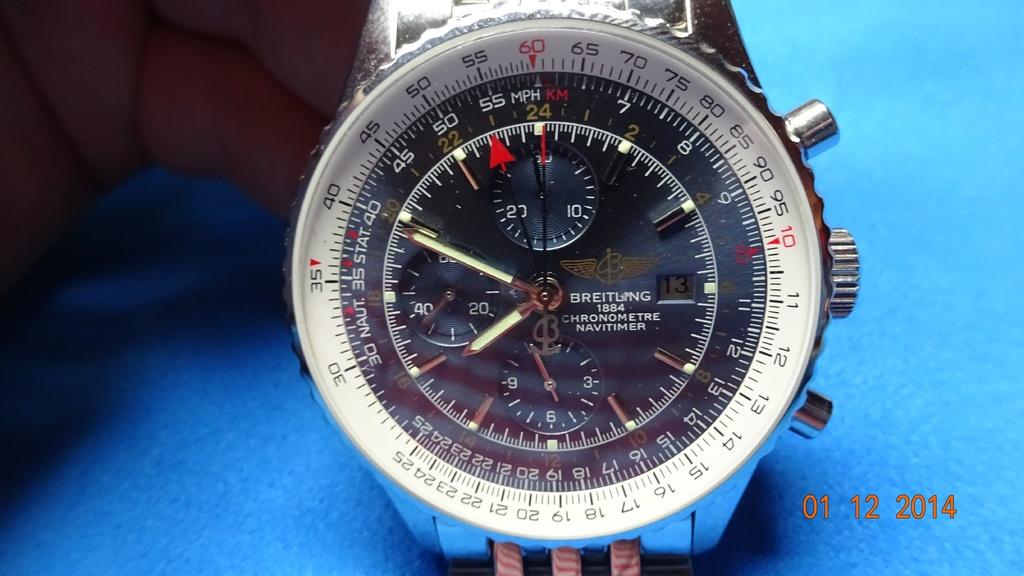What time is on the watch?
Ensure brevity in your answer.  7:49. What is the brand of the watch?
Your answer should be compact. Breitling. 